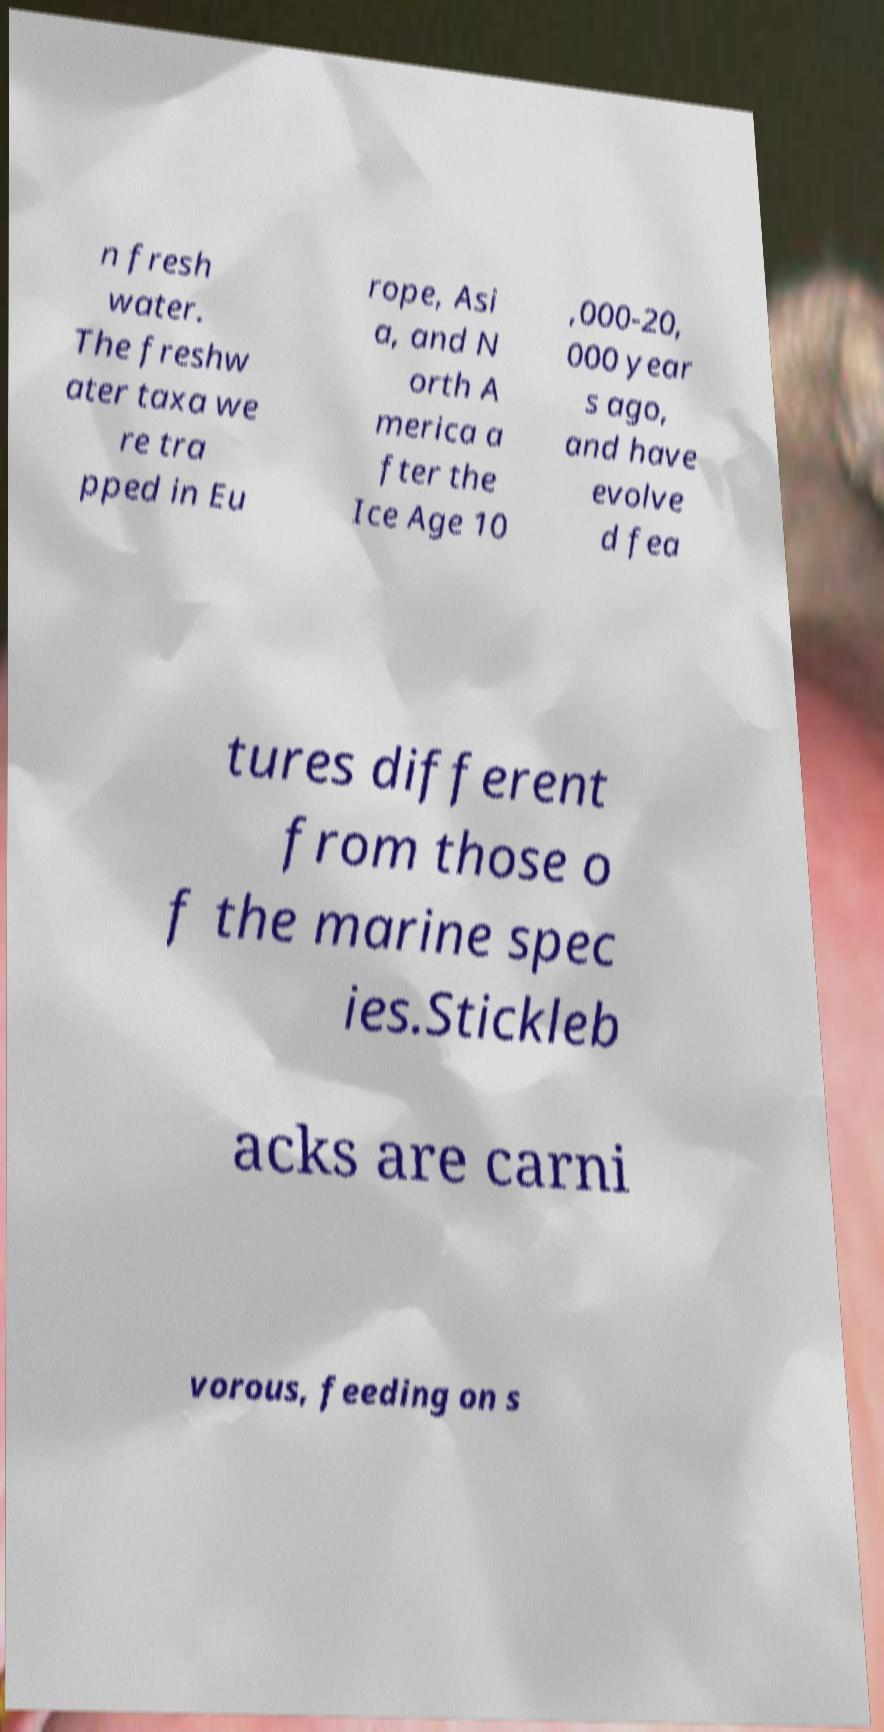I need the written content from this picture converted into text. Can you do that? n fresh water. The freshw ater taxa we re tra pped in Eu rope, Asi a, and N orth A merica a fter the Ice Age 10 ,000-20, 000 year s ago, and have evolve d fea tures different from those o f the marine spec ies.Stickleb acks are carni vorous, feeding on s 